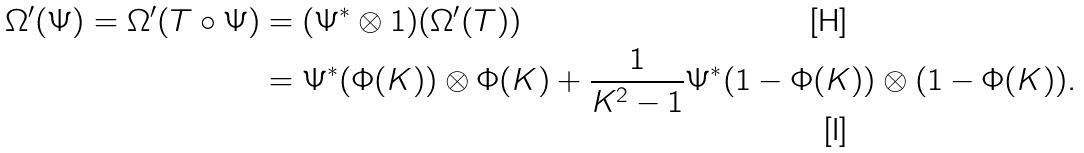Convert formula to latex. <formula><loc_0><loc_0><loc_500><loc_500>\Omega ^ { \prime } ( \Psi ) = \Omega ^ { \prime } ( { T } \circ \Psi ) & = ( \Psi ^ { * } \otimes 1 ) ( \Omega ^ { \prime } ( { T } ) ) \\ & = \Psi ^ { * } ( \Phi ( K ) ) \otimes \Phi ( K ) + \frac { 1 } { K ^ { 2 } - 1 } \Psi ^ { * } ( 1 - \Phi ( K ) ) \otimes ( 1 - \Phi ( K ) ) .</formula> 